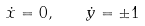Convert formula to latex. <formula><loc_0><loc_0><loc_500><loc_500>\dot { x } = 0 , \quad \dot { y } = \pm 1</formula> 